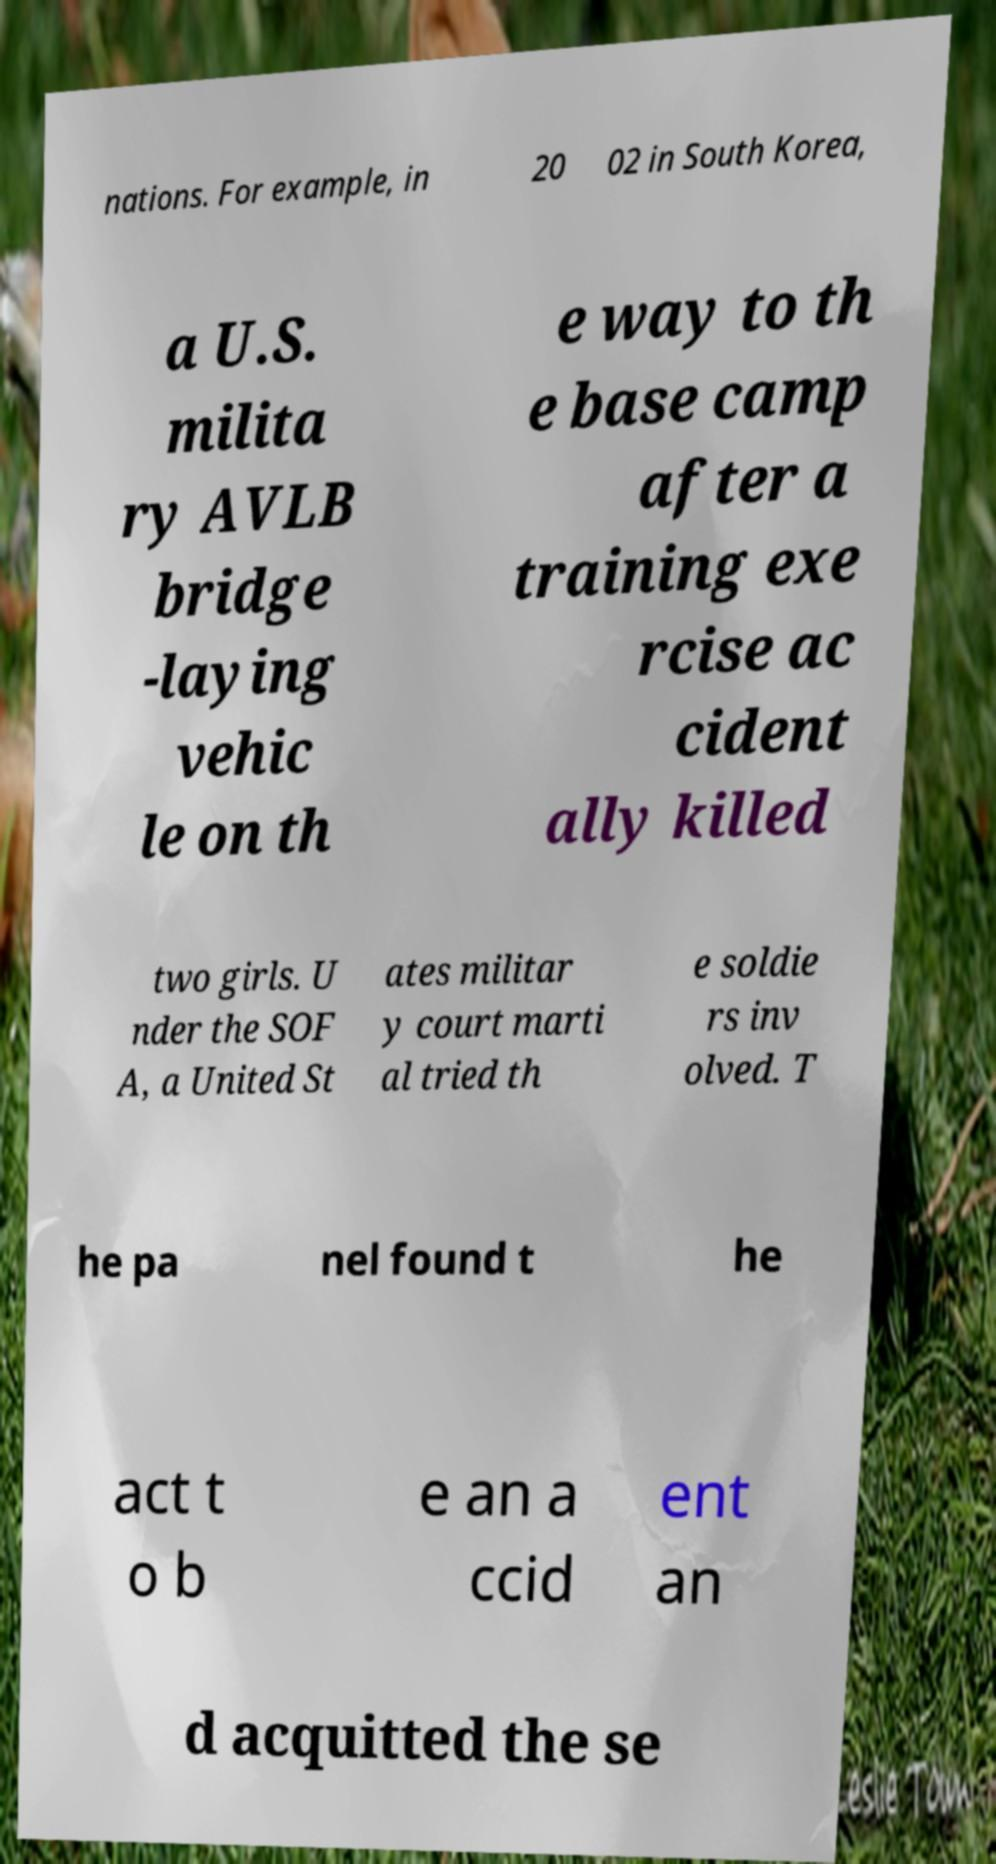Could you assist in decoding the text presented in this image and type it out clearly? nations. For example, in 20 02 in South Korea, a U.S. milita ry AVLB bridge -laying vehic le on th e way to th e base camp after a training exe rcise ac cident ally killed two girls. U nder the SOF A, a United St ates militar y court marti al tried th e soldie rs inv olved. T he pa nel found t he act t o b e an a ccid ent an d acquitted the se 